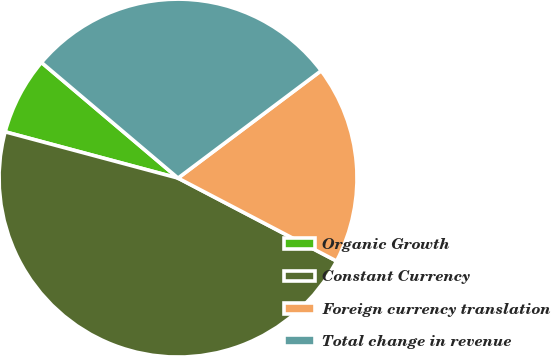<chart> <loc_0><loc_0><loc_500><loc_500><pie_chart><fcel>Organic Growth<fcel>Constant Currency<fcel>Foreign currency translation<fcel>Total change in revenue<nl><fcel>7.02%<fcel>46.49%<fcel>17.92%<fcel>28.57%<nl></chart> 